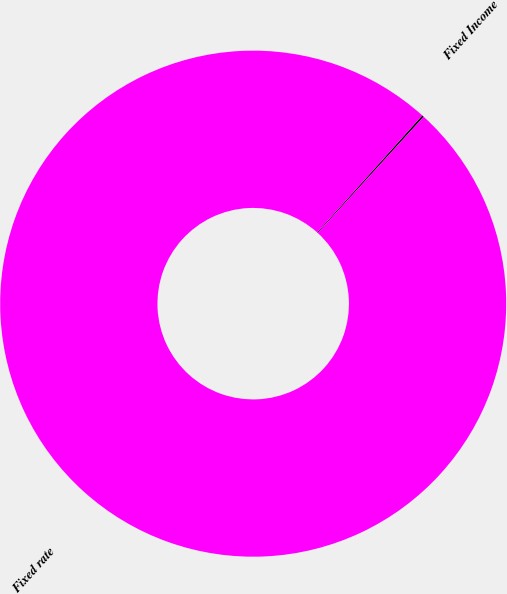Convert chart. <chart><loc_0><loc_0><loc_500><loc_500><pie_chart><fcel>Fixed Income<fcel>Fixed rate<nl><fcel>0.12%<fcel>99.88%<nl></chart> 